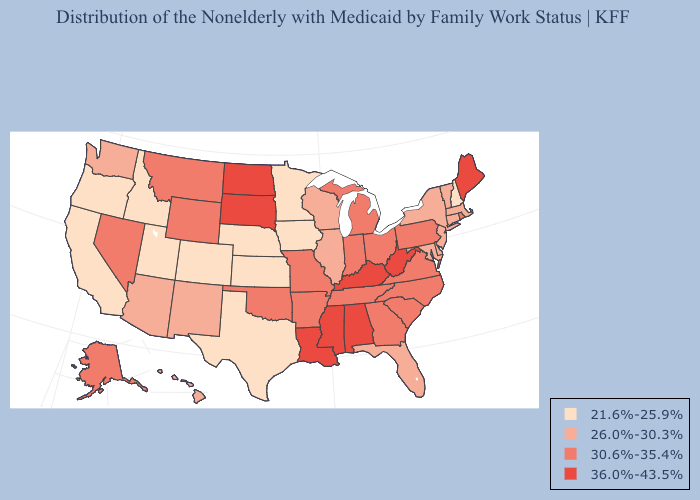What is the lowest value in states that border Wisconsin?
Answer briefly. 21.6%-25.9%. What is the value of Mississippi?
Quick response, please. 36.0%-43.5%. What is the lowest value in the USA?
Short answer required. 21.6%-25.9%. What is the lowest value in the South?
Keep it brief. 21.6%-25.9%. What is the highest value in the West ?
Concise answer only. 30.6%-35.4%. Which states have the lowest value in the MidWest?
Answer briefly. Iowa, Kansas, Minnesota, Nebraska. Does the first symbol in the legend represent the smallest category?
Concise answer only. Yes. Among the states that border New York , does Pennsylvania have the lowest value?
Answer briefly. No. Which states have the lowest value in the USA?
Give a very brief answer. California, Colorado, Idaho, Iowa, Kansas, Minnesota, Nebraska, New Hampshire, Oregon, Texas, Utah. Among the states that border Colorado , does Arizona have the lowest value?
Write a very short answer. No. Name the states that have a value in the range 36.0%-43.5%?
Be succinct. Alabama, Kentucky, Louisiana, Maine, Mississippi, North Dakota, South Dakota, West Virginia. Name the states that have a value in the range 21.6%-25.9%?
Give a very brief answer. California, Colorado, Idaho, Iowa, Kansas, Minnesota, Nebraska, New Hampshire, Oregon, Texas, Utah. Does Louisiana have the highest value in the USA?
Be succinct. Yes. Name the states that have a value in the range 26.0%-30.3%?
Be succinct. Arizona, Connecticut, Delaware, Florida, Hawaii, Illinois, Maryland, Massachusetts, New Jersey, New Mexico, New York, Vermont, Washington, Wisconsin. What is the value of South Dakota?
Short answer required. 36.0%-43.5%. 